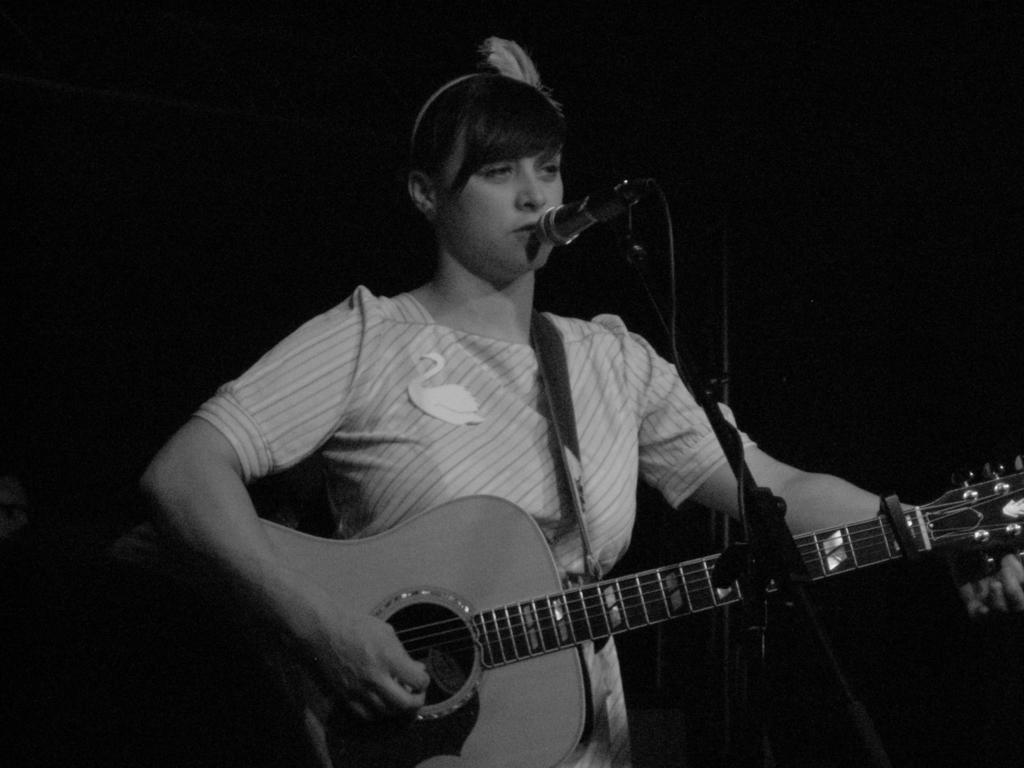What is the main subject of the image? The main subject of the image is a woman. What is the woman doing in the image? The woman is standing, playing a guitar, and singing. What is in front of the woman? There is a microphone and a microphone stand in front of her. How would you describe the lighting in the image? The background of the image is dark. What is the distance between the woman and her nerves in the image? There is no mention of nerves in the image, so it is not possible to determine the distance between the woman and her nerves. 